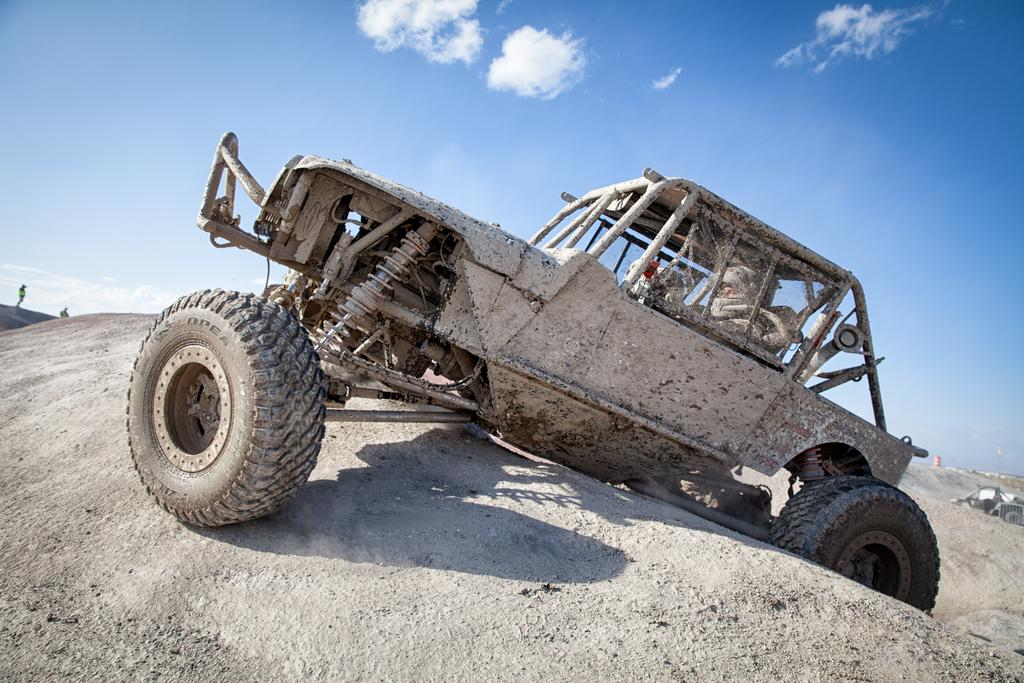What is located on the hill in the image? There is a vehicle on the hill in the image. What else can be seen in the background of the image? There are people in the background of the image. What is visible at the top of the image? The sky is visible at the top of the image. Can you tell me how many lizards are sitting on the vehicle in the image? There are no lizards present in the image; it only features a vehicle on the hill and people in the background. What type of quill is being used by the people in the image? There is no quill visible in the image; the people are not depicted using any writing instrument. 